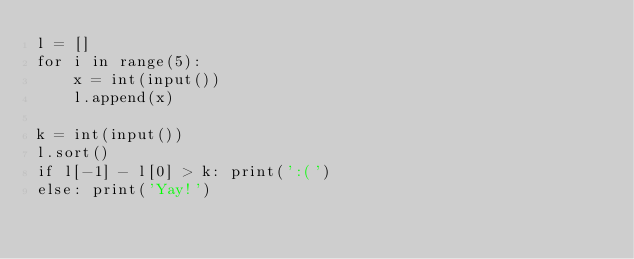Convert code to text. <code><loc_0><loc_0><loc_500><loc_500><_Python_>l = []
for i in range(5):
    x = int(input())
    l.append(x)

k = int(input())
l.sort()
if l[-1] - l[0] > k: print(':(')
else: print('Yay!')</code> 